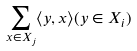Convert formula to latex. <formula><loc_0><loc_0><loc_500><loc_500>\sum _ { x \in X _ { j } } \langle y , x \rangle ( y \in X _ { i } )</formula> 